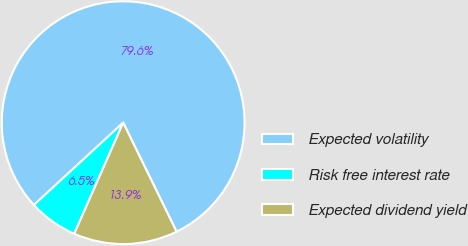<chart> <loc_0><loc_0><loc_500><loc_500><pie_chart><fcel>Expected volatility<fcel>Risk free interest rate<fcel>Expected dividend yield<nl><fcel>79.61%<fcel>6.54%<fcel>13.85%<nl></chart> 